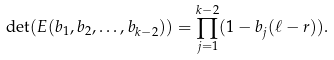<formula> <loc_0><loc_0><loc_500><loc_500>\det ( E ( b _ { 1 } , b _ { 2 } , \dots , b _ { k - 2 } ) ) = \prod _ { j = 1 } ^ { k - 2 } ( 1 - b _ { j } ( \ell - r ) ) .</formula> 